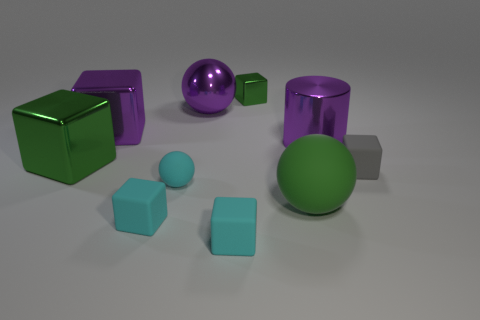Subtract all cyan rubber blocks. How many blocks are left? 4 Subtract all purple cubes. How many cubes are left? 5 Subtract all balls. How many objects are left? 7 Subtract all gray balls. How many green cubes are left? 2 Subtract 2 spheres. How many spheres are left? 1 Add 6 gray rubber things. How many gray rubber things are left? 7 Add 6 tiny cyan matte blocks. How many tiny cyan matte blocks exist? 8 Subtract 1 gray cubes. How many objects are left? 9 Subtract all blue blocks. Subtract all gray spheres. How many blocks are left? 6 Subtract all small shiny blocks. Subtract all large green matte objects. How many objects are left? 8 